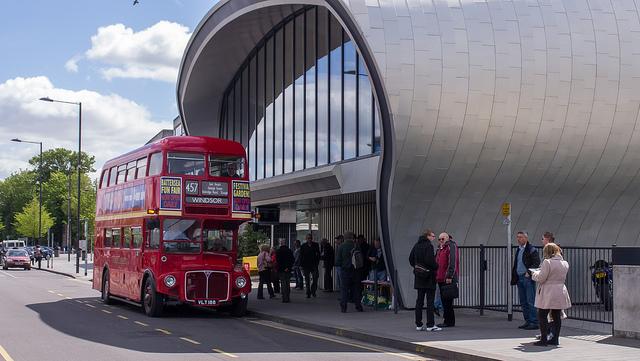Is this a train station?
Write a very short answer. No. How many levels are in this bus?
Be succinct. 2. Are the people to the far right waiting for the bus?
Concise answer only. Yes. What color is the bus?
Give a very brief answer. Red. 